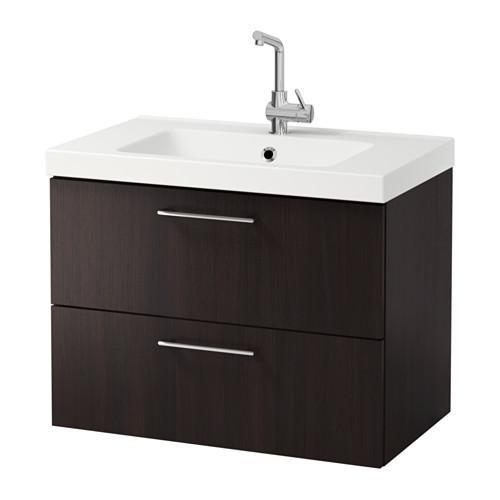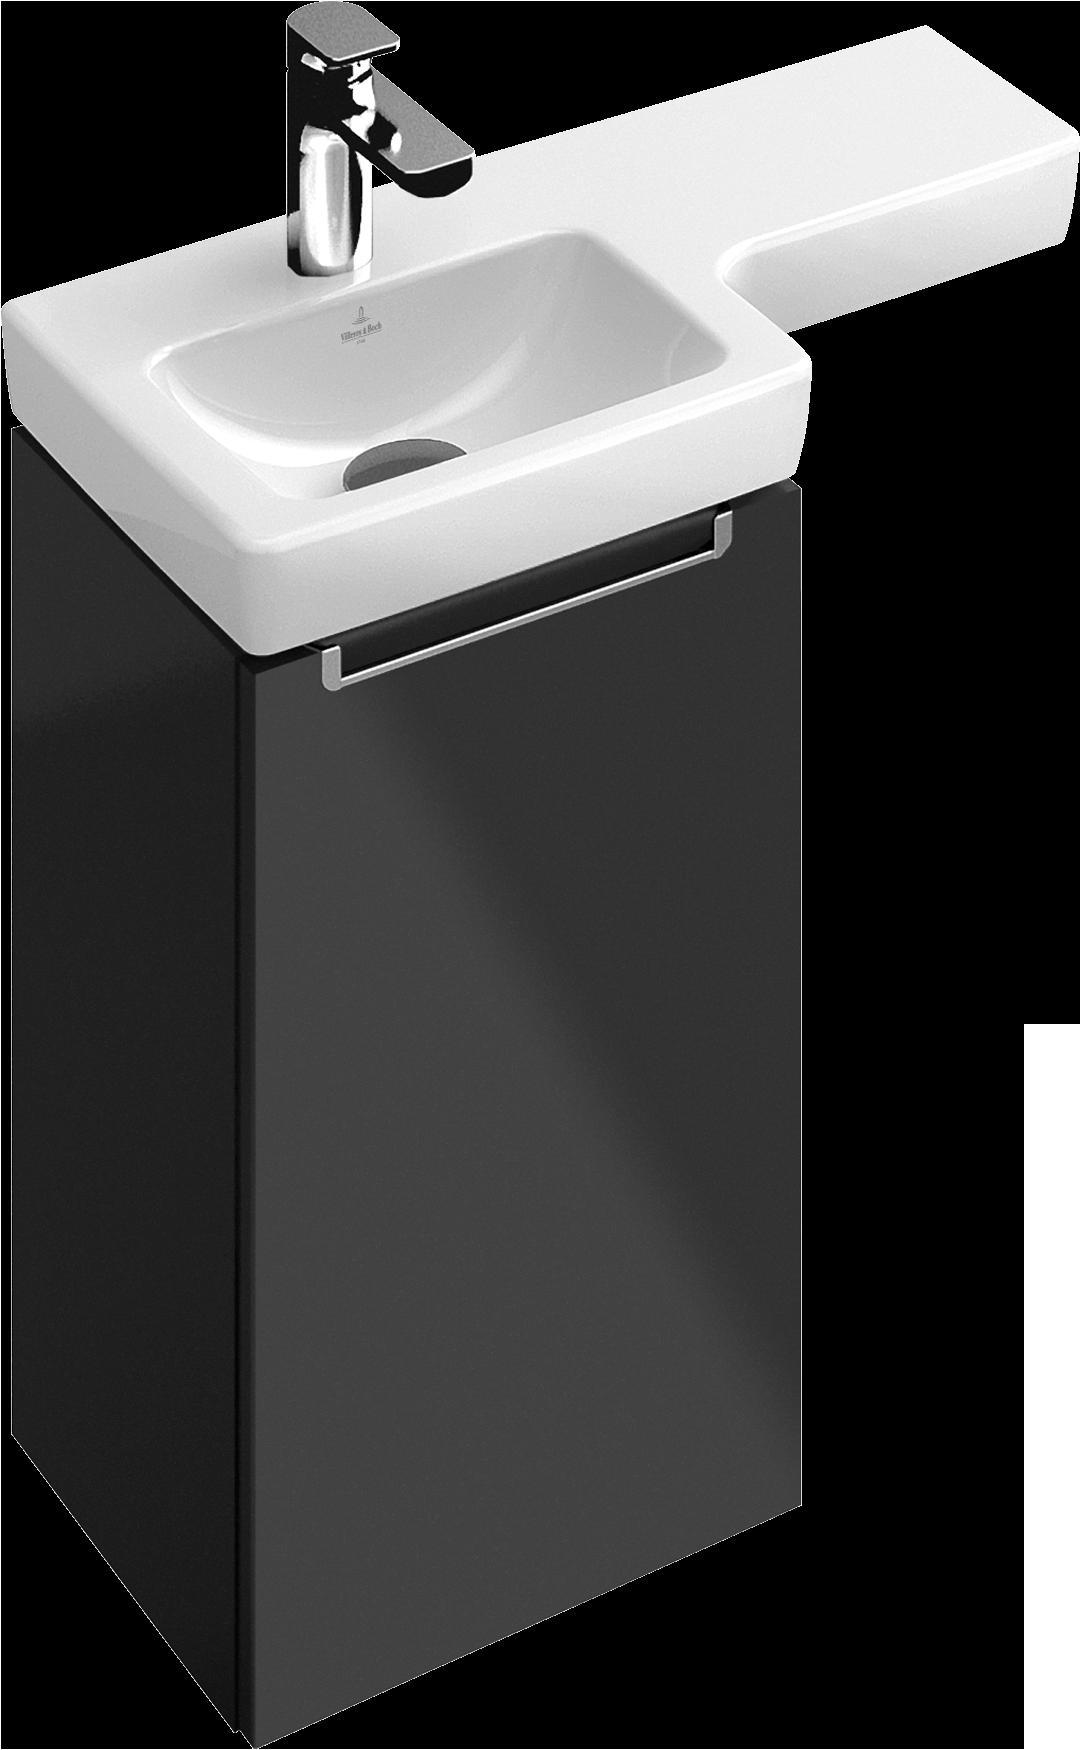The first image is the image on the left, the second image is the image on the right. Considering the images on both sides, is "The left image features a white rectangular wall-mounted sink with its spout on the right side and a box shape underneath that does not extend to the floor." valid? Answer yes or no. No. The first image is the image on the left, the second image is the image on the right. Considering the images on both sides, is "The door on one of the cabinets is open." valid? Answer yes or no. No. 